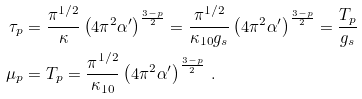<formula> <loc_0><loc_0><loc_500><loc_500>\tau _ { p } & = \frac { \pi ^ { 1 / 2 } } { \kappa } \left ( 4 \pi ^ { 2 } \alpha ^ { \prime } \right ) ^ { \frac { 3 - p } { 2 } } = \frac { \pi ^ { 1 / 2 } } { \kappa _ { 1 0 } g _ { s } } \left ( 4 \pi ^ { 2 } \alpha ^ { \prime } \right ) ^ { \frac { 3 - p } { 2 } } = \frac { T _ { p } } { g _ { s } } \\ \mu _ { p } & = T _ { p } = \frac { \pi ^ { 1 / 2 } } { \kappa _ { 1 0 } } \left ( 4 \pi ^ { 2 } \alpha ^ { \prime } \right ) ^ { \frac { 3 - p } { 2 } } \, .</formula> 